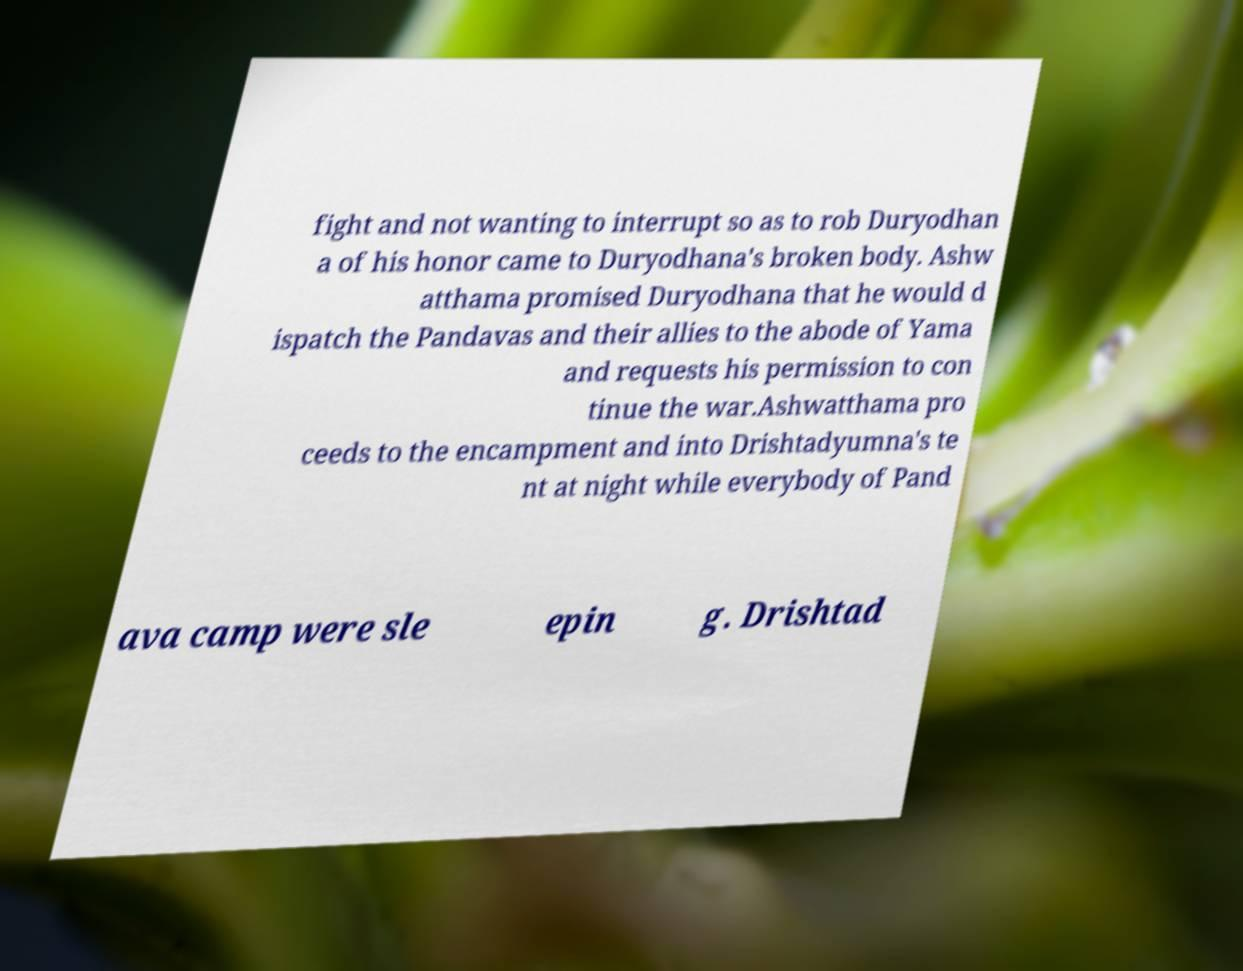What messages or text are displayed in this image? I need them in a readable, typed format. fight and not wanting to interrupt so as to rob Duryodhan a of his honor came to Duryodhana's broken body. Ashw atthama promised Duryodhana that he would d ispatch the Pandavas and their allies to the abode of Yama and requests his permission to con tinue the war.Ashwatthama pro ceeds to the encampment and into Drishtadyumna's te nt at night while everybody of Pand ava camp were sle epin g. Drishtad 